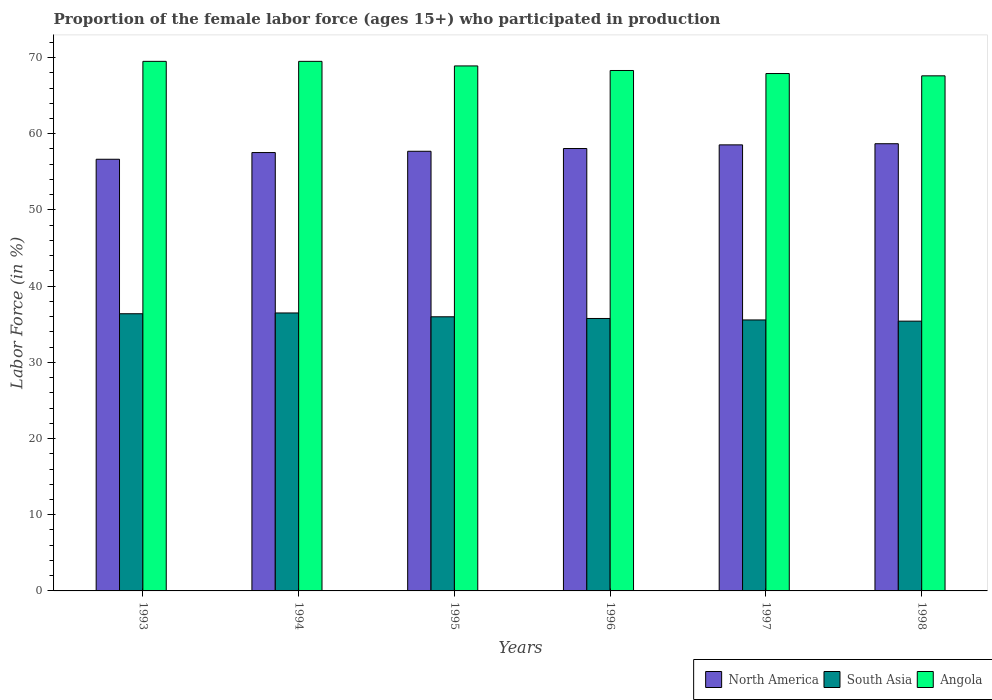How many different coloured bars are there?
Give a very brief answer. 3. How many groups of bars are there?
Provide a succinct answer. 6. Are the number of bars on each tick of the X-axis equal?
Provide a succinct answer. Yes. How many bars are there on the 4th tick from the right?
Ensure brevity in your answer.  3. What is the label of the 4th group of bars from the left?
Give a very brief answer. 1996. In how many cases, is the number of bars for a given year not equal to the number of legend labels?
Your answer should be very brief. 0. What is the proportion of the female labor force who participated in production in South Asia in 1993?
Keep it short and to the point. 36.38. Across all years, what is the maximum proportion of the female labor force who participated in production in Angola?
Your response must be concise. 69.5. Across all years, what is the minimum proportion of the female labor force who participated in production in Angola?
Offer a very short reply. 67.6. What is the total proportion of the female labor force who participated in production in South Asia in the graph?
Provide a succinct answer. 215.55. What is the difference between the proportion of the female labor force who participated in production in South Asia in 1997 and that in 1998?
Your answer should be compact. 0.16. What is the difference between the proportion of the female labor force who participated in production in Angola in 1993 and the proportion of the female labor force who participated in production in North America in 1996?
Make the answer very short. 11.44. What is the average proportion of the female labor force who participated in production in Angola per year?
Make the answer very short. 68.62. In the year 1995, what is the difference between the proportion of the female labor force who participated in production in Angola and proportion of the female labor force who participated in production in North America?
Your answer should be very brief. 11.2. In how many years, is the proportion of the female labor force who participated in production in Angola greater than 42 %?
Keep it short and to the point. 6. What is the ratio of the proportion of the female labor force who participated in production in Angola in 1993 to that in 1996?
Offer a very short reply. 1.02. Is the proportion of the female labor force who participated in production in North America in 1993 less than that in 1997?
Offer a very short reply. Yes. What is the difference between the highest and the second highest proportion of the female labor force who participated in production in North America?
Offer a terse response. 0.15. What is the difference between the highest and the lowest proportion of the female labor force who participated in production in North America?
Offer a very short reply. 2.04. In how many years, is the proportion of the female labor force who participated in production in South Asia greater than the average proportion of the female labor force who participated in production in South Asia taken over all years?
Provide a succinct answer. 3. Is the sum of the proportion of the female labor force who participated in production in Angola in 1993 and 1994 greater than the maximum proportion of the female labor force who participated in production in South Asia across all years?
Your answer should be compact. Yes. What does the 3rd bar from the right in 1995 represents?
Your response must be concise. North America. Is it the case that in every year, the sum of the proportion of the female labor force who participated in production in Angola and proportion of the female labor force who participated in production in South Asia is greater than the proportion of the female labor force who participated in production in North America?
Make the answer very short. Yes. Are the values on the major ticks of Y-axis written in scientific E-notation?
Provide a succinct answer. No. Does the graph contain any zero values?
Give a very brief answer. No. How many legend labels are there?
Provide a short and direct response. 3. How are the legend labels stacked?
Your answer should be very brief. Horizontal. What is the title of the graph?
Keep it short and to the point. Proportion of the female labor force (ages 15+) who participated in production. What is the label or title of the X-axis?
Provide a succinct answer. Years. What is the Labor Force (in %) in North America in 1993?
Your response must be concise. 56.65. What is the Labor Force (in %) of South Asia in 1993?
Provide a succinct answer. 36.38. What is the Labor Force (in %) of Angola in 1993?
Ensure brevity in your answer.  69.5. What is the Labor Force (in %) of North America in 1994?
Your answer should be very brief. 57.53. What is the Labor Force (in %) in South Asia in 1994?
Provide a succinct answer. 36.48. What is the Labor Force (in %) in Angola in 1994?
Your answer should be compact. 69.5. What is the Labor Force (in %) of North America in 1995?
Offer a terse response. 57.7. What is the Labor Force (in %) in South Asia in 1995?
Provide a succinct answer. 35.98. What is the Labor Force (in %) of Angola in 1995?
Your response must be concise. 68.9. What is the Labor Force (in %) of North America in 1996?
Your response must be concise. 58.06. What is the Labor Force (in %) of South Asia in 1996?
Your answer should be compact. 35.76. What is the Labor Force (in %) in Angola in 1996?
Offer a terse response. 68.3. What is the Labor Force (in %) of North America in 1997?
Offer a very short reply. 58.54. What is the Labor Force (in %) in South Asia in 1997?
Keep it short and to the point. 35.56. What is the Labor Force (in %) of Angola in 1997?
Give a very brief answer. 67.9. What is the Labor Force (in %) in North America in 1998?
Provide a short and direct response. 58.69. What is the Labor Force (in %) in South Asia in 1998?
Give a very brief answer. 35.4. What is the Labor Force (in %) of Angola in 1998?
Your answer should be compact. 67.6. Across all years, what is the maximum Labor Force (in %) of North America?
Offer a very short reply. 58.69. Across all years, what is the maximum Labor Force (in %) in South Asia?
Make the answer very short. 36.48. Across all years, what is the maximum Labor Force (in %) in Angola?
Ensure brevity in your answer.  69.5. Across all years, what is the minimum Labor Force (in %) of North America?
Ensure brevity in your answer.  56.65. Across all years, what is the minimum Labor Force (in %) of South Asia?
Provide a short and direct response. 35.4. Across all years, what is the minimum Labor Force (in %) of Angola?
Your answer should be very brief. 67.6. What is the total Labor Force (in %) in North America in the graph?
Give a very brief answer. 347.17. What is the total Labor Force (in %) of South Asia in the graph?
Your answer should be compact. 215.55. What is the total Labor Force (in %) in Angola in the graph?
Your answer should be very brief. 411.7. What is the difference between the Labor Force (in %) in North America in 1993 and that in 1994?
Keep it short and to the point. -0.88. What is the difference between the Labor Force (in %) in South Asia in 1993 and that in 1994?
Provide a succinct answer. -0.1. What is the difference between the Labor Force (in %) in North America in 1993 and that in 1995?
Your answer should be compact. -1.05. What is the difference between the Labor Force (in %) in South Asia in 1993 and that in 1995?
Offer a terse response. 0.4. What is the difference between the Labor Force (in %) of North America in 1993 and that in 1996?
Your answer should be very brief. -1.41. What is the difference between the Labor Force (in %) in South Asia in 1993 and that in 1996?
Ensure brevity in your answer.  0.62. What is the difference between the Labor Force (in %) in North America in 1993 and that in 1997?
Ensure brevity in your answer.  -1.89. What is the difference between the Labor Force (in %) in South Asia in 1993 and that in 1997?
Provide a succinct answer. 0.82. What is the difference between the Labor Force (in %) in Angola in 1993 and that in 1997?
Provide a succinct answer. 1.6. What is the difference between the Labor Force (in %) of North America in 1993 and that in 1998?
Provide a succinct answer. -2.04. What is the difference between the Labor Force (in %) of South Asia in 1993 and that in 1998?
Provide a succinct answer. 0.97. What is the difference between the Labor Force (in %) in North America in 1994 and that in 1995?
Offer a very short reply. -0.17. What is the difference between the Labor Force (in %) of South Asia in 1994 and that in 1995?
Offer a terse response. 0.5. What is the difference between the Labor Force (in %) in North America in 1994 and that in 1996?
Keep it short and to the point. -0.53. What is the difference between the Labor Force (in %) in South Asia in 1994 and that in 1996?
Offer a very short reply. 0.72. What is the difference between the Labor Force (in %) in Angola in 1994 and that in 1996?
Provide a short and direct response. 1.2. What is the difference between the Labor Force (in %) in North America in 1994 and that in 1997?
Make the answer very short. -1.01. What is the difference between the Labor Force (in %) of South Asia in 1994 and that in 1997?
Your response must be concise. 0.92. What is the difference between the Labor Force (in %) in North America in 1994 and that in 1998?
Keep it short and to the point. -1.16. What is the difference between the Labor Force (in %) in South Asia in 1994 and that in 1998?
Your answer should be very brief. 1.07. What is the difference between the Labor Force (in %) in Angola in 1994 and that in 1998?
Your response must be concise. 1.9. What is the difference between the Labor Force (in %) in North America in 1995 and that in 1996?
Provide a succinct answer. -0.36. What is the difference between the Labor Force (in %) in South Asia in 1995 and that in 1996?
Your response must be concise. 0.22. What is the difference between the Labor Force (in %) in North America in 1995 and that in 1997?
Your answer should be very brief. -0.84. What is the difference between the Labor Force (in %) of South Asia in 1995 and that in 1997?
Give a very brief answer. 0.41. What is the difference between the Labor Force (in %) in North America in 1995 and that in 1998?
Offer a very short reply. -0.99. What is the difference between the Labor Force (in %) of South Asia in 1995 and that in 1998?
Provide a succinct answer. 0.57. What is the difference between the Labor Force (in %) in Angola in 1995 and that in 1998?
Provide a succinct answer. 1.3. What is the difference between the Labor Force (in %) in North America in 1996 and that in 1997?
Make the answer very short. -0.48. What is the difference between the Labor Force (in %) in South Asia in 1996 and that in 1997?
Offer a terse response. 0.19. What is the difference between the Labor Force (in %) in North America in 1996 and that in 1998?
Your answer should be very brief. -0.63. What is the difference between the Labor Force (in %) in South Asia in 1996 and that in 1998?
Offer a very short reply. 0.35. What is the difference between the Labor Force (in %) of Angola in 1996 and that in 1998?
Your response must be concise. 0.7. What is the difference between the Labor Force (in %) of North America in 1997 and that in 1998?
Provide a succinct answer. -0.15. What is the difference between the Labor Force (in %) of South Asia in 1997 and that in 1998?
Ensure brevity in your answer.  0.16. What is the difference between the Labor Force (in %) of Angola in 1997 and that in 1998?
Ensure brevity in your answer.  0.3. What is the difference between the Labor Force (in %) of North America in 1993 and the Labor Force (in %) of South Asia in 1994?
Keep it short and to the point. 20.17. What is the difference between the Labor Force (in %) of North America in 1993 and the Labor Force (in %) of Angola in 1994?
Keep it short and to the point. -12.85. What is the difference between the Labor Force (in %) in South Asia in 1993 and the Labor Force (in %) in Angola in 1994?
Provide a succinct answer. -33.12. What is the difference between the Labor Force (in %) of North America in 1993 and the Labor Force (in %) of South Asia in 1995?
Give a very brief answer. 20.67. What is the difference between the Labor Force (in %) of North America in 1993 and the Labor Force (in %) of Angola in 1995?
Make the answer very short. -12.25. What is the difference between the Labor Force (in %) in South Asia in 1993 and the Labor Force (in %) in Angola in 1995?
Make the answer very short. -32.52. What is the difference between the Labor Force (in %) in North America in 1993 and the Labor Force (in %) in South Asia in 1996?
Keep it short and to the point. 20.9. What is the difference between the Labor Force (in %) in North America in 1993 and the Labor Force (in %) in Angola in 1996?
Offer a terse response. -11.65. What is the difference between the Labor Force (in %) in South Asia in 1993 and the Labor Force (in %) in Angola in 1996?
Your response must be concise. -31.92. What is the difference between the Labor Force (in %) in North America in 1993 and the Labor Force (in %) in South Asia in 1997?
Ensure brevity in your answer.  21.09. What is the difference between the Labor Force (in %) in North America in 1993 and the Labor Force (in %) in Angola in 1997?
Keep it short and to the point. -11.25. What is the difference between the Labor Force (in %) in South Asia in 1993 and the Labor Force (in %) in Angola in 1997?
Make the answer very short. -31.52. What is the difference between the Labor Force (in %) in North America in 1993 and the Labor Force (in %) in South Asia in 1998?
Your response must be concise. 21.25. What is the difference between the Labor Force (in %) of North America in 1993 and the Labor Force (in %) of Angola in 1998?
Keep it short and to the point. -10.95. What is the difference between the Labor Force (in %) of South Asia in 1993 and the Labor Force (in %) of Angola in 1998?
Ensure brevity in your answer.  -31.22. What is the difference between the Labor Force (in %) of North America in 1994 and the Labor Force (in %) of South Asia in 1995?
Offer a terse response. 21.55. What is the difference between the Labor Force (in %) of North America in 1994 and the Labor Force (in %) of Angola in 1995?
Ensure brevity in your answer.  -11.37. What is the difference between the Labor Force (in %) of South Asia in 1994 and the Labor Force (in %) of Angola in 1995?
Offer a very short reply. -32.42. What is the difference between the Labor Force (in %) of North America in 1994 and the Labor Force (in %) of South Asia in 1996?
Offer a terse response. 21.77. What is the difference between the Labor Force (in %) in North America in 1994 and the Labor Force (in %) in Angola in 1996?
Make the answer very short. -10.77. What is the difference between the Labor Force (in %) in South Asia in 1994 and the Labor Force (in %) in Angola in 1996?
Your answer should be compact. -31.82. What is the difference between the Labor Force (in %) in North America in 1994 and the Labor Force (in %) in South Asia in 1997?
Your answer should be very brief. 21.97. What is the difference between the Labor Force (in %) in North America in 1994 and the Labor Force (in %) in Angola in 1997?
Give a very brief answer. -10.37. What is the difference between the Labor Force (in %) in South Asia in 1994 and the Labor Force (in %) in Angola in 1997?
Provide a succinct answer. -31.42. What is the difference between the Labor Force (in %) of North America in 1994 and the Labor Force (in %) of South Asia in 1998?
Your response must be concise. 22.13. What is the difference between the Labor Force (in %) of North America in 1994 and the Labor Force (in %) of Angola in 1998?
Ensure brevity in your answer.  -10.07. What is the difference between the Labor Force (in %) in South Asia in 1994 and the Labor Force (in %) in Angola in 1998?
Your answer should be very brief. -31.12. What is the difference between the Labor Force (in %) in North America in 1995 and the Labor Force (in %) in South Asia in 1996?
Your answer should be very brief. 21.94. What is the difference between the Labor Force (in %) of North America in 1995 and the Labor Force (in %) of Angola in 1996?
Offer a very short reply. -10.6. What is the difference between the Labor Force (in %) of South Asia in 1995 and the Labor Force (in %) of Angola in 1996?
Keep it short and to the point. -32.32. What is the difference between the Labor Force (in %) in North America in 1995 and the Labor Force (in %) in South Asia in 1997?
Your answer should be compact. 22.14. What is the difference between the Labor Force (in %) of North America in 1995 and the Labor Force (in %) of Angola in 1997?
Provide a succinct answer. -10.2. What is the difference between the Labor Force (in %) in South Asia in 1995 and the Labor Force (in %) in Angola in 1997?
Your response must be concise. -31.92. What is the difference between the Labor Force (in %) of North America in 1995 and the Labor Force (in %) of South Asia in 1998?
Give a very brief answer. 22.3. What is the difference between the Labor Force (in %) in North America in 1995 and the Labor Force (in %) in Angola in 1998?
Your answer should be very brief. -9.9. What is the difference between the Labor Force (in %) of South Asia in 1995 and the Labor Force (in %) of Angola in 1998?
Give a very brief answer. -31.62. What is the difference between the Labor Force (in %) of North America in 1996 and the Labor Force (in %) of South Asia in 1997?
Your answer should be compact. 22.5. What is the difference between the Labor Force (in %) in North America in 1996 and the Labor Force (in %) in Angola in 1997?
Provide a short and direct response. -9.84. What is the difference between the Labor Force (in %) of South Asia in 1996 and the Labor Force (in %) of Angola in 1997?
Ensure brevity in your answer.  -32.15. What is the difference between the Labor Force (in %) in North America in 1996 and the Labor Force (in %) in South Asia in 1998?
Ensure brevity in your answer.  22.66. What is the difference between the Labor Force (in %) of North America in 1996 and the Labor Force (in %) of Angola in 1998?
Make the answer very short. -9.54. What is the difference between the Labor Force (in %) in South Asia in 1996 and the Labor Force (in %) in Angola in 1998?
Your response must be concise. -31.84. What is the difference between the Labor Force (in %) in North America in 1997 and the Labor Force (in %) in South Asia in 1998?
Offer a terse response. 23.14. What is the difference between the Labor Force (in %) in North America in 1997 and the Labor Force (in %) in Angola in 1998?
Offer a very short reply. -9.06. What is the difference between the Labor Force (in %) of South Asia in 1997 and the Labor Force (in %) of Angola in 1998?
Your answer should be very brief. -32.04. What is the average Labor Force (in %) of North America per year?
Make the answer very short. 57.86. What is the average Labor Force (in %) of South Asia per year?
Offer a terse response. 35.93. What is the average Labor Force (in %) of Angola per year?
Your response must be concise. 68.62. In the year 1993, what is the difference between the Labor Force (in %) of North America and Labor Force (in %) of South Asia?
Offer a very short reply. 20.27. In the year 1993, what is the difference between the Labor Force (in %) of North America and Labor Force (in %) of Angola?
Your answer should be very brief. -12.85. In the year 1993, what is the difference between the Labor Force (in %) of South Asia and Labor Force (in %) of Angola?
Your response must be concise. -33.12. In the year 1994, what is the difference between the Labor Force (in %) in North America and Labor Force (in %) in South Asia?
Provide a succinct answer. 21.05. In the year 1994, what is the difference between the Labor Force (in %) of North America and Labor Force (in %) of Angola?
Provide a succinct answer. -11.97. In the year 1994, what is the difference between the Labor Force (in %) in South Asia and Labor Force (in %) in Angola?
Your answer should be compact. -33.02. In the year 1995, what is the difference between the Labor Force (in %) of North America and Labor Force (in %) of South Asia?
Your answer should be compact. 21.72. In the year 1995, what is the difference between the Labor Force (in %) in North America and Labor Force (in %) in Angola?
Offer a terse response. -11.2. In the year 1995, what is the difference between the Labor Force (in %) in South Asia and Labor Force (in %) in Angola?
Provide a short and direct response. -32.92. In the year 1996, what is the difference between the Labor Force (in %) of North America and Labor Force (in %) of South Asia?
Your response must be concise. 22.3. In the year 1996, what is the difference between the Labor Force (in %) in North America and Labor Force (in %) in Angola?
Your answer should be very brief. -10.24. In the year 1996, what is the difference between the Labor Force (in %) of South Asia and Labor Force (in %) of Angola?
Provide a succinct answer. -32.55. In the year 1997, what is the difference between the Labor Force (in %) in North America and Labor Force (in %) in South Asia?
Ensure brevity in your answer.  22.98. In the year 1997, what is the difference between the Labor Force (in %) of North America and Labor Force (in %) of Angola?
Your answer should be very brief. -9.36. In the year 1997, what is the difference between the Labor Force (in %) in South Asia and Labor Force (in %) in Angola?
Make the answer very short. -32.34. In the year 1998, what is the difference between the Labor Force (in %) in North America and Labor Force (in %) in South Asia?
Your answer should be compact. 23.29. In the year 1998, what is the difference between the Labor Force (in %) of North America and Labor Force (in %) of Angola?
Make the answer very short. -8.91. In the year 1998, what is the difference between the Labor Force (in %) in South Asia and Labor Force (in %) in Angola?
Your answer should be compact. -32.2. What is the ratio of the Labor Force (in %) of North America in 1993 to that in 1994?
Your answer should be compact. 0.98. What is the ratio of the Labor Force (in %) of Angola in 1993 to that in 1994?
Keep it short and to the point. 1. What is the ratio of the Labor Force (in %) of North America in 1993 to that in 1995?
Offer a terse response. 0.98. What is the ratio of the Labor Force (in %) of South Asia in 1993 to that in 1995?
Provide a succinct answer. 1.01. What is the ratio of the Labor Force (in %) of Angola in 1993 to that in 1995?
Provide a short and direct response. 1.01. What is the ratio of the Labor Force (in %) of North America in 1993 to that in 1996?
Offer a very short reply. 0.98. What is the ratio of the Labor Force (in %) of South Asia in 1993 to that in 1996?
Keep it short and to the point. 1.02. What is the ratio of the Labor Force (in %) of Angola in 1993 to that in 1996?
Ensure brevity in your answer.  1.02. What is the ratio of the Labor Force (in %) of South Asia in 1993 to that in 1997?
Your answer should be very brief. 1.02. What is the ratio of the Labor Force (in %) in Angola in 1993 to that in 1997?
Offer a terse response. 1.02. What is the ratio of the Labor Force (in %) of North America in 1993 to that in 1998?
Offer a very short reply. 0.97. What is the ratio of the Labor Force (in %) in South Asia in 1993 to that in 1998?
Your answer should be compact. 1.03. What is the ratio of the Labor Force (in %) in Angola in 1993 to that in 1998?
Give a very brief answer. 1.03. What is the ratio of the Labor Force (in %) in North America in 1994 to that in 1995?
Ensure brevity in your answer.  1. What is the ratio of the Labor Force (in %) in Angola in 1994 to that in 1995?
Your response must be concise. 1.01. What is the ratio of the Labor Force (in %) in North America in 1994 to that in 1996?
Your answer should be compact. 0.99. What is the ratio of the Labor Force (in %) in South Asia in 1994 to that in 1996?
Provide a succinct answer. 1.02. What is the ratio of the Labor Force (in %) of Angola in 1994 to that in 1996?
Provide a succinct answer. 1.02. What is the ratio of the Labor Force (in %) of North America in 1994 to that in 1997?
Provide a succinct answer. 0.98. What is the ratio of the Labor Force (in %) in South Asia in 1994 to that in 1997?
Your answer should be very brief. 1.03. What is the ratio of the Labor Force (in %) of Angola in 1994 to that in 1997?
Your answer should be compact. 1.02. What is the ratio of the Labor Force (in %) of North America in 1994 to that in 1998?
Provide a short and direct response. 0.98. What is the ratio of the Labor Force (in %) of South Asia in 1994 to that in 1998?
Provide a short and direct response. 1.03. What is the ratio of the Labor Force (in %) of Angola in 1994 to that in 1998?
Give a very brief answer. 1.03. What is the ratio of the Labor Force (in %) in South Asia in 1995 to that in 1996?
Offer a very short reply. 1.01. What is the ratio of the Labor Force (in %) of Angola in 1995 to that in 1996?
Your response must be concise. 1.01. What is the ratio of the Labor Force (in %) of North America in 1995 to that in 1997?
Your response must be concise. 0.99. What is the ratio of the Labor Force (in %) in South Asia in 1995 to that in 1997?
Offer a terse response. 1.01. What is the ratio of the Labor Force (in %) of Angola in 1995 to that in 1997?
Offer a very short reply. 1.01. What is the ratio of the Labor Force (in %) of North America in 1995 to that in 1998?
Your response must be concise. 0.98. What is the ratio of the Labor Force (in %) of South Asia in 1995 to that in 1998?
Your answer should be very brief. 1.02. What is the ratio of the Labor Force (in %) in Angola in 1995 to that in 1998?
Offer a very short reply. 1.02. What is the ratio of the Labor Force (in %) in South Asia in 1996 to that in 1997?
Offer a very short reply. 1.01. What is the ratio of the Labor Force (in %) of Angola in 1996 to that in 1997?
Offer a terse response. 1.01. What is the ratio of the Labor Force (in %) of North America in 1996 to that in 1998?
Your response must be concise. 0.99. What is the ratio of the Labor Force (in %) in South Asia in 1996 to that in 1998?
Offer a terse response. 1.01. What is the ratio of the Labor Force (in %) in Angola in 1996 to that in 1998?
Give a very brief answer. 1.01. What is the difference between the highest and the second highest Labor Force (in %) of North America?
Your answer should be very brief. 0.15. What is the difference between the highest and the second highest Labor Force (in %) of South Asia?
Provide a succinct answer. 0.1. What is the difference between the highest and the second highest Labor Force (in %) of Angola?
Your response must be concise. 0. What is the difference between the highest and the lowest Labor Force (in %) in North America?
Your answer should be compact. 2.04. What is the difference between the highest and the lowest Labor Force (in %) in South Asia?
Make the answer very short. 1.07. What is the difference between the highest and the lowest Labor Force (in %) in Angola?
Your answer should be compact. 1.9. 